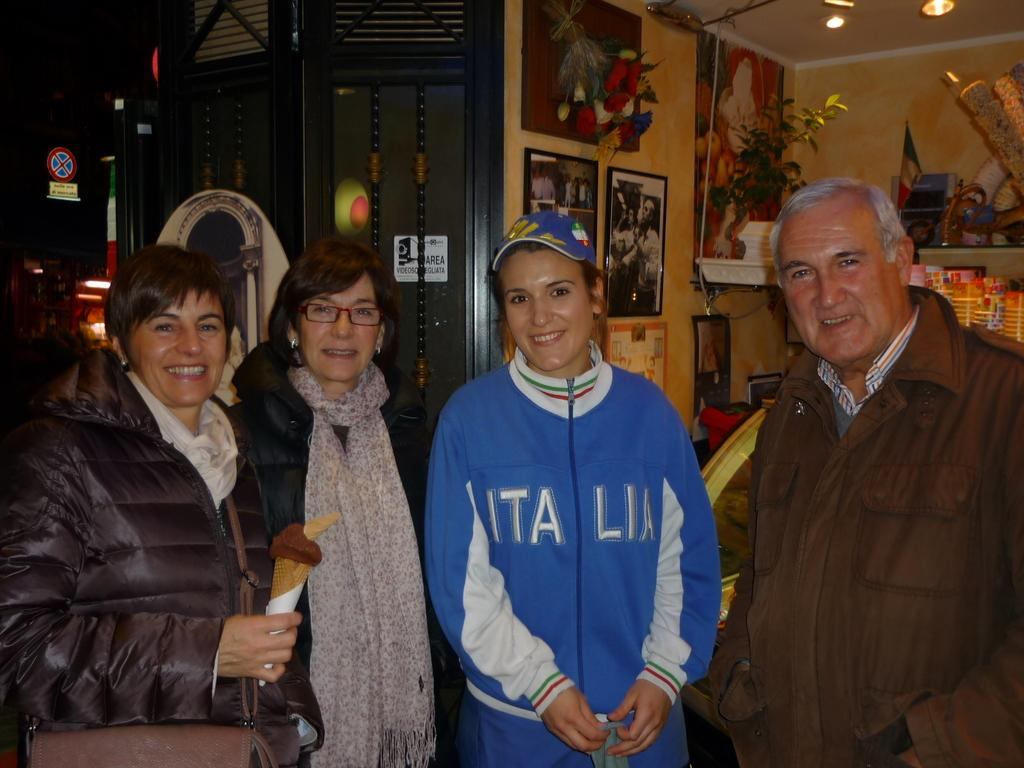<image>
Provide a brief description of the given image. A woman with a blue Italia sweatshirt standing in a group of 4 people. 